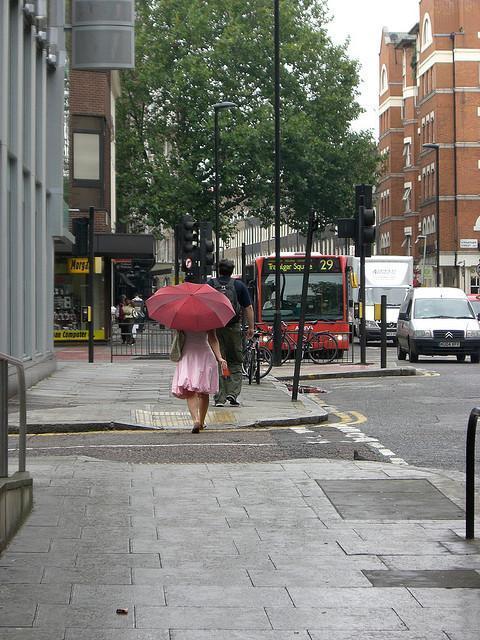How many umbrellas are open?
Give a very brief answer. 1. How many umbrellas are in the picture?
Give a very brief answer. 1. How many people can be seen?
Give a very brief answer. 2. How many white airplanes do you see?
Give a very brief answer. 0. 